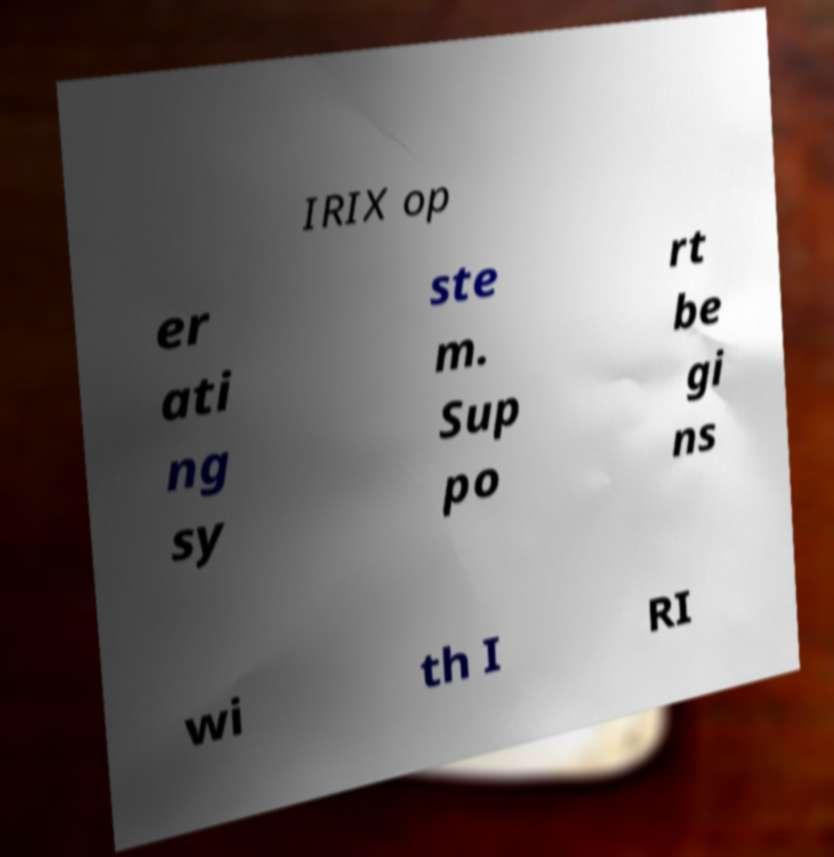Please identify and transcribe the text found in this image. IRIX op er ati ng sy ste m. Sup po rt be gi ns wi th I RI 